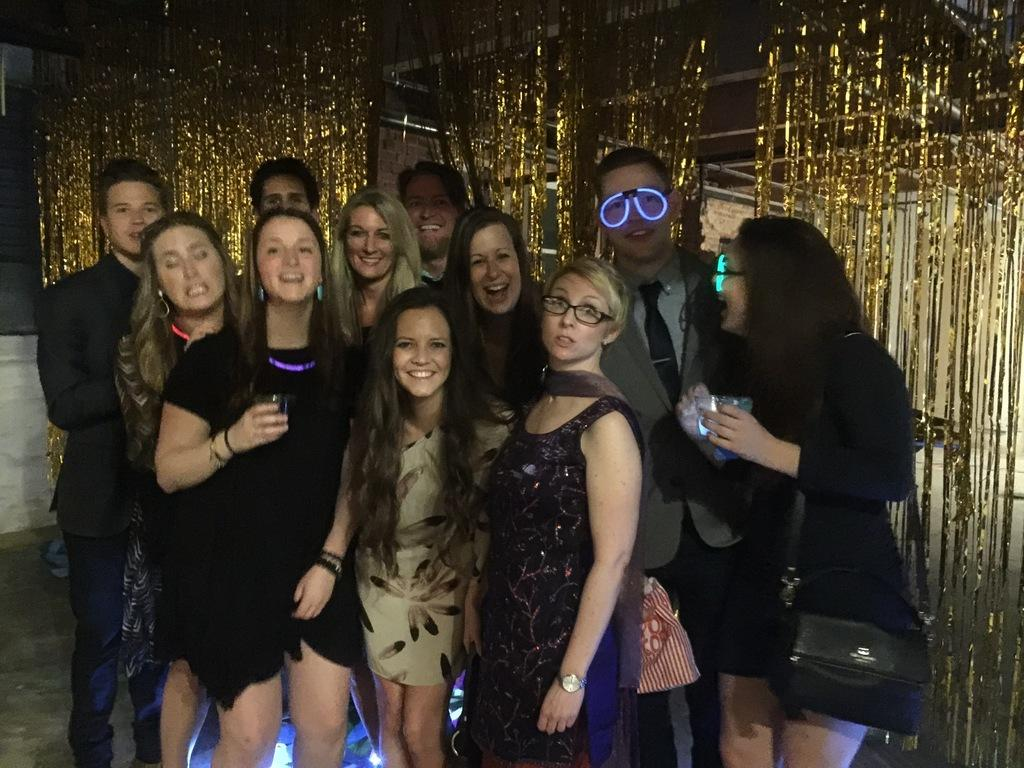What can be seen in the image regarding human presence? There are people standing in the image. What surface are the people standing on? The people are standing on the floor. Can you describe any specific clothing or accessories worn by the people? There is a person wearing light goggles. What type of decoration can be seen in the image? There are golden decoration items visible in the image. How much sugar is present in the image? There is no sugar present in the image; it features people standing on the floor and golden decoration items. 